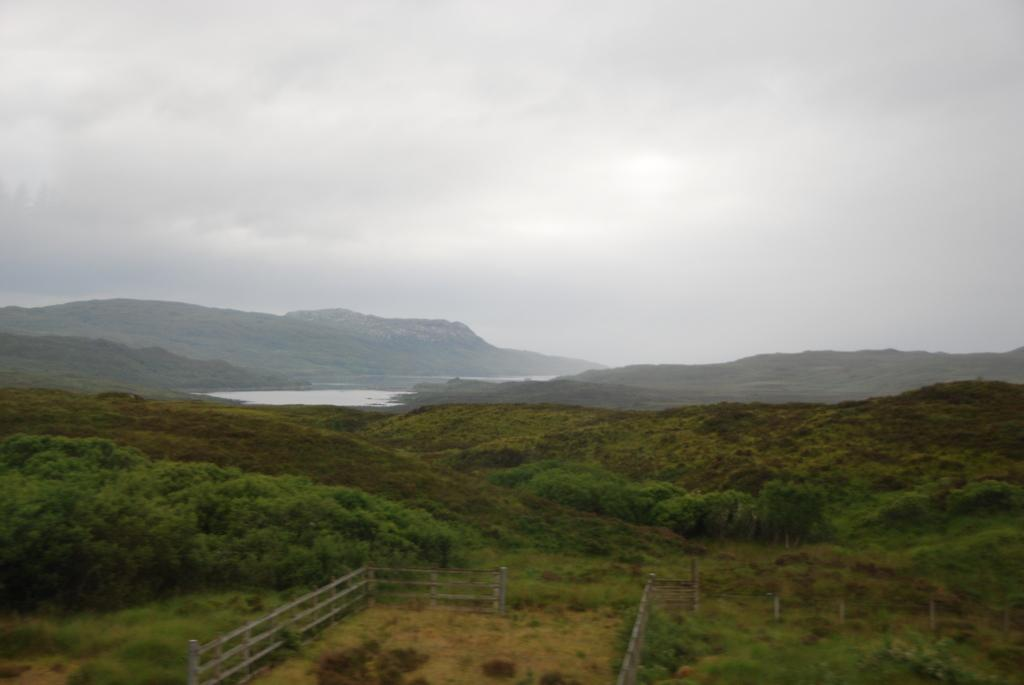What type of vegetation can be seen in the image? There are trees in the image. What structure is present in the image? There is a fence in the image. What natural feature can be seen in the image? There is water visible in the image. What type of landscape is depicted in the image? There are hills in the image. What is the condition of the sky in the image? The sky is cloudy in the image. Can you tell me how many zebras are grazing near the trees in the image? There are no zebras present in the image; it features trees, a fence, water, hills, and a cloudy sky. What type of plant is growing on the hills in the image? The provided facts do not mention any specific plants growing on the hills in the image. 